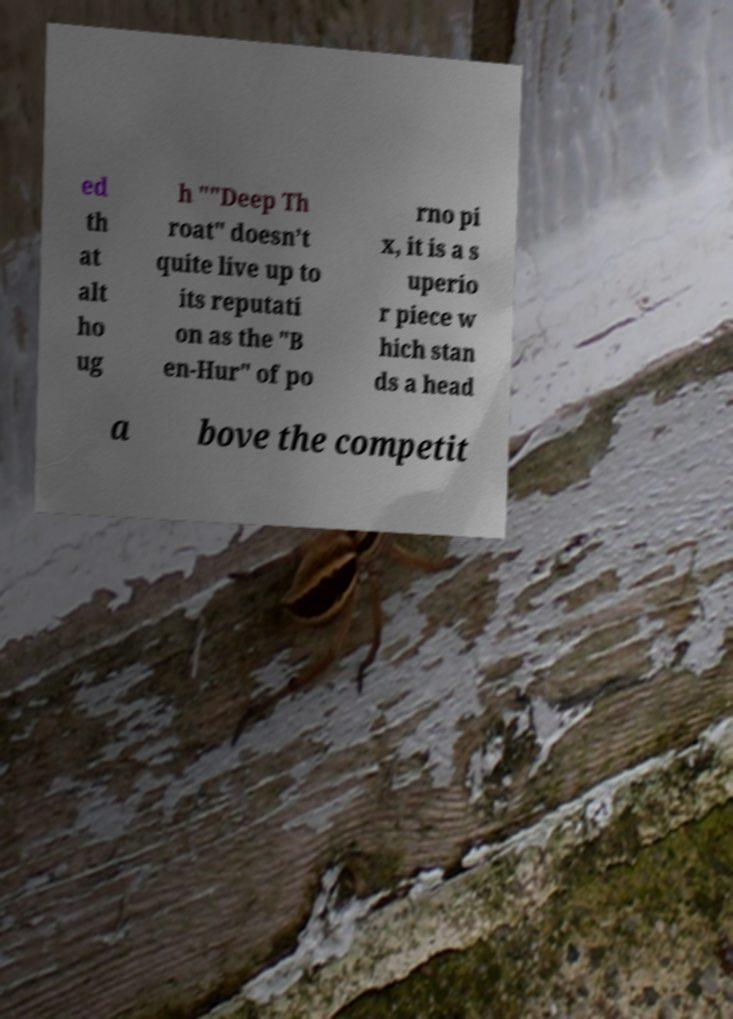I need the written content from this picture converted into text. Can you do that? ed th at alt ho ug h ""Deep Th roat" doesn’t quite live up to its reputati on as the "B en-Hur" of po rno pi x, it is a s uperio r piece w hich stan ds a head a bove the competit 